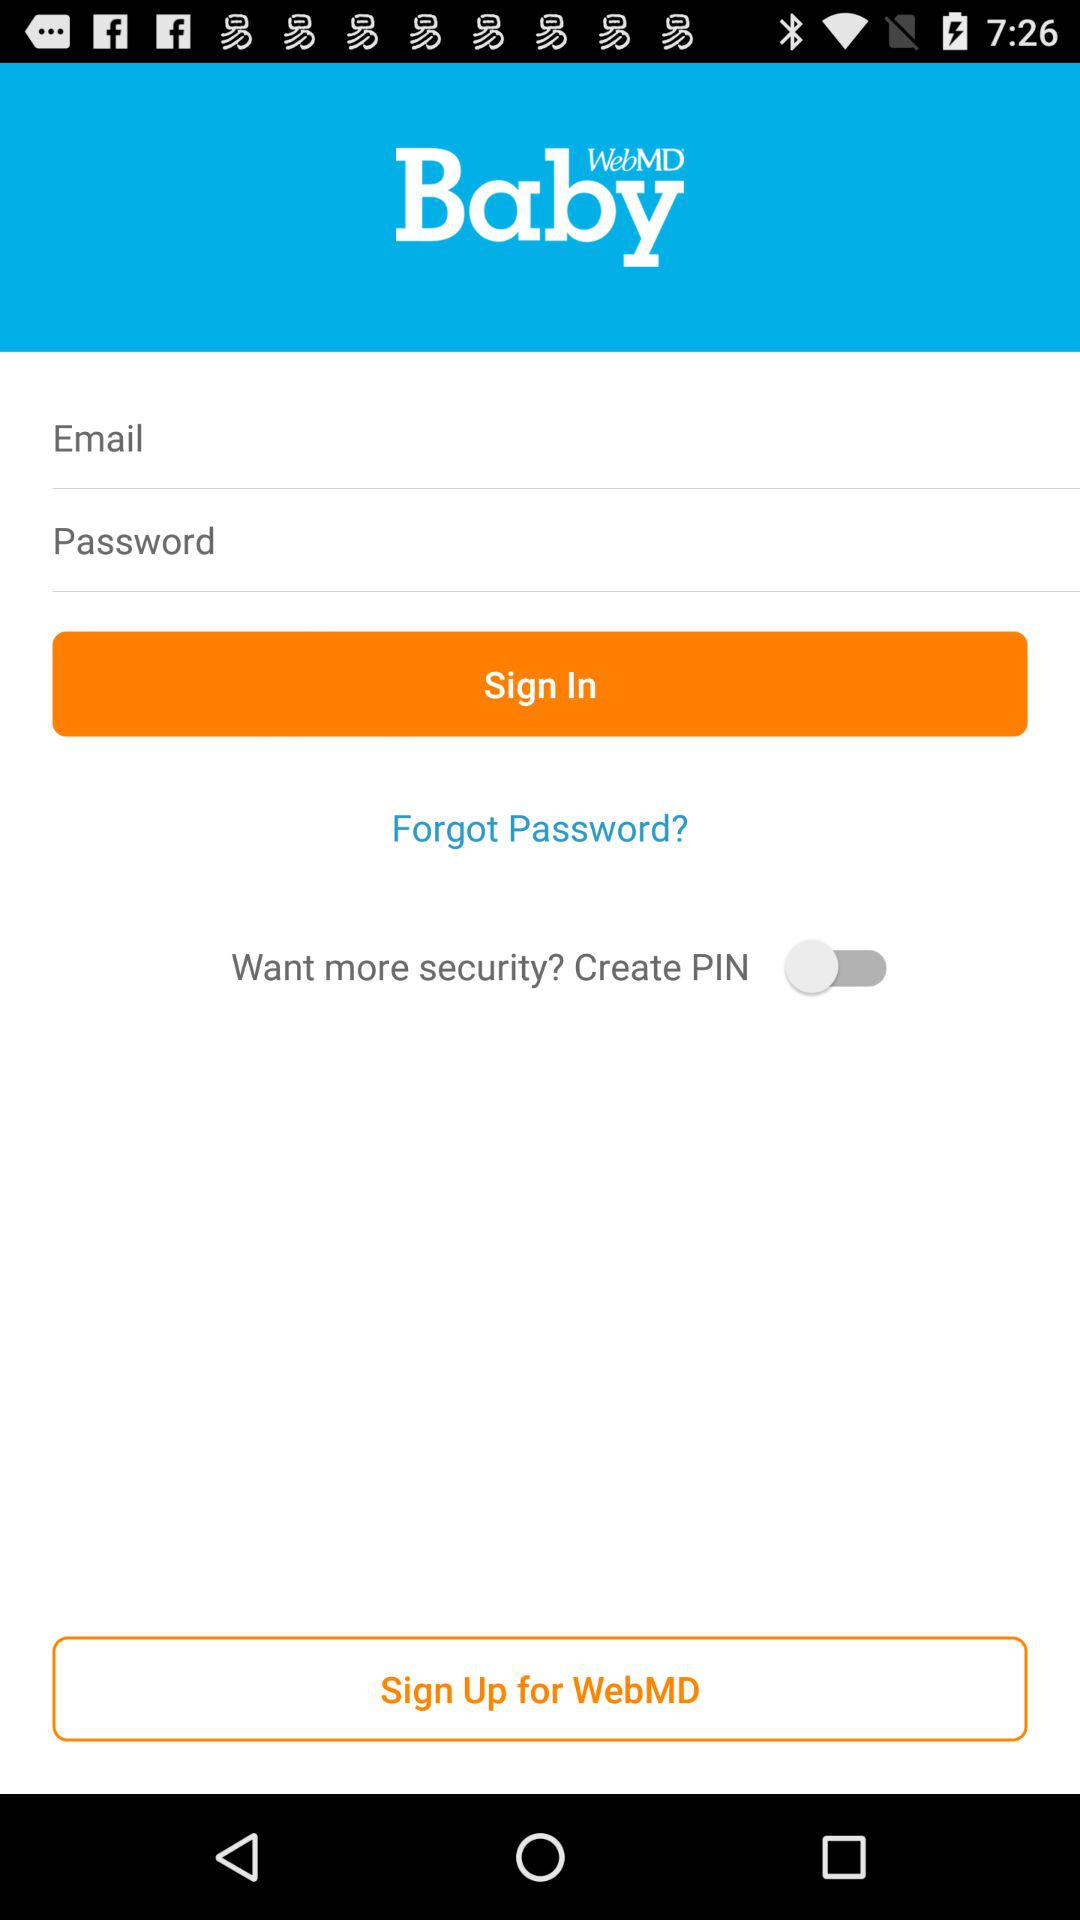What is the app name? The app name is "WebMD". 